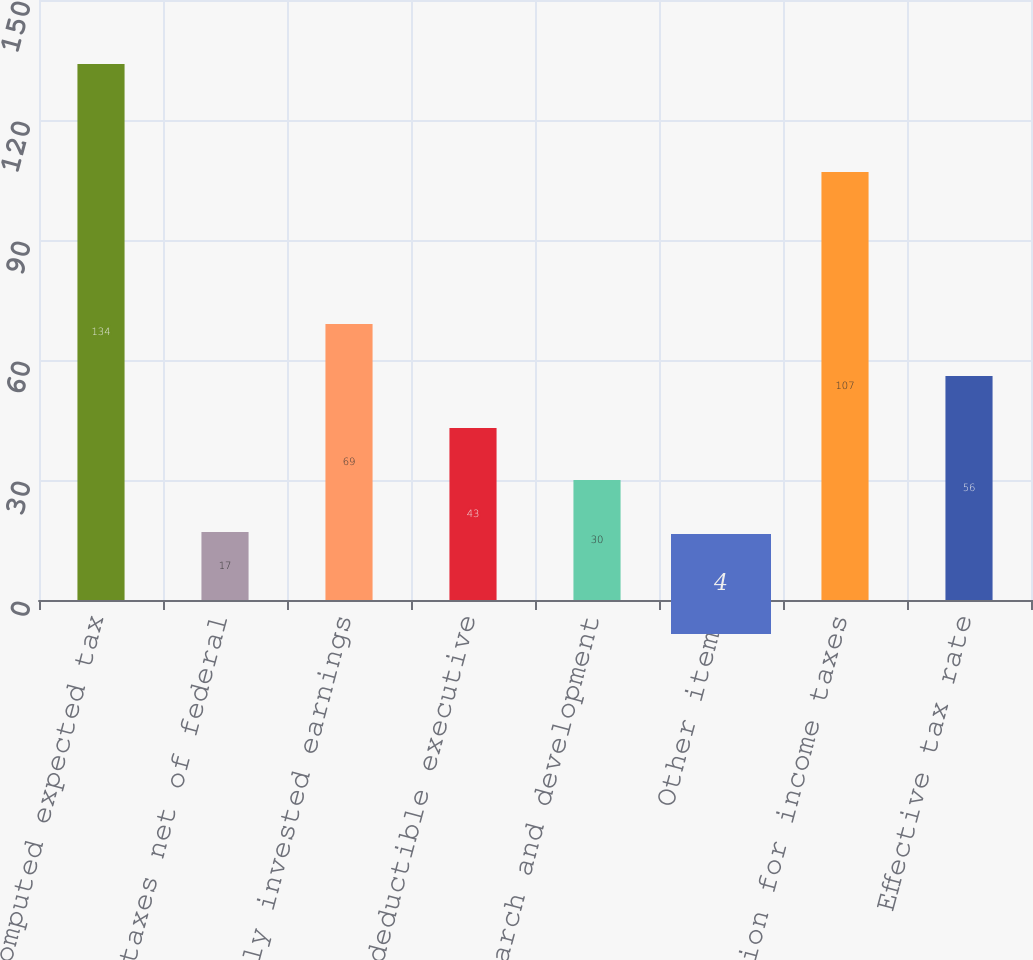Convert chart. <chart><loc_0><loc_0><loc_500><loc_500><bar_chart><fcel>Computed expected tax<fcel>State taxes net of federal<fcel>Indefinitely invested earnings<fcel>Nondeductible executive<fcel>Research and development<fcel>Other items<fcel>Provision for income taxes<fcel>Effective tax rate<nl><fcel>134<fcel>17<fcel>69<fcel>43<fcel>30<fcel>4<fcel>107<fcel>56<nl></chart> 